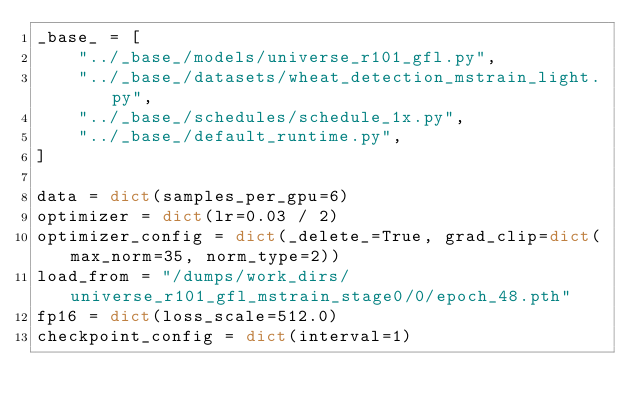Convert code to text. <code><loc_0><loc_0><loc_500><loc_500><_Python_>_base_ = [
    "../_base_/models/universe_r101_gfl.py",
    "../_base_/datasets/wheat_detection_mstrain_light.py",
    "../_base_/schedules/schedule_1x.py",
    "../_base_/default_runtime.py",
]

data = dict(samples_per_gpu=6)
optimizer = dict(lr=0.03 / 2)
optimizer_config = dict(_delete_=True, grad_clip=dict(max_norm=35, norm_type=2))
load_from = "/dumps/work_dirs/universe_r101_gfl_mstrain_stage0/0/epoch_48.pth"
fp16 = dict(loss_scale=512.0)
checkpoint_config = dict(interval=1)
</code> 